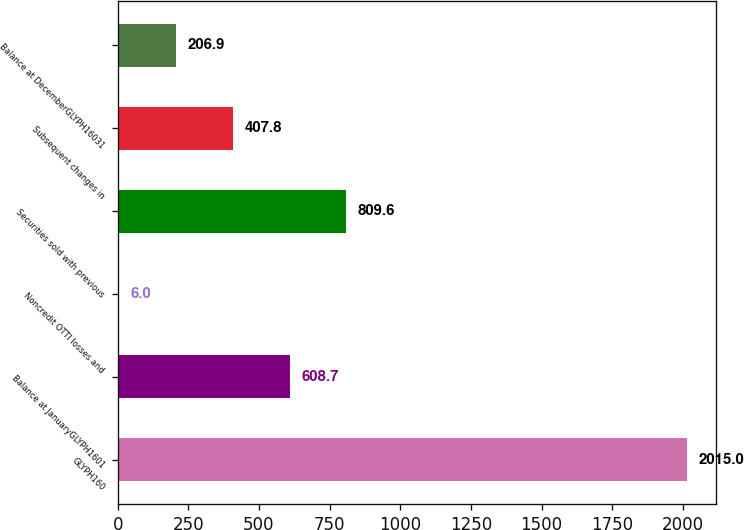Convert chart to OTSL. <chart><loc_0><loc_0><loc_500><loc_500><bar_chart><fcel>GLYPH160<fcel>Balance at JanuaryGLYPH1601<fcel>Noncredit OTTI losses and<fcel>Securities sold with previous<fcel>Subsequent changes in<fcel>Balance at DecemberGLYPH16031<nl><fcel>2015<fcel>608.7<fcel>6<fcel>809.6<fcel>407.8<fcel>206.9<nl></chart> 